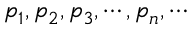Convert formula to latex. <formula><loc_0><loc_0><loc_500><loc_500>\mathfrak { p } _ { 1 } , \mathfrak { p } _ { 2 } , \mathfrak { p } _ { 3 } , \cdots , \mathfrak { p } _ { n } , \cdots</formula> 